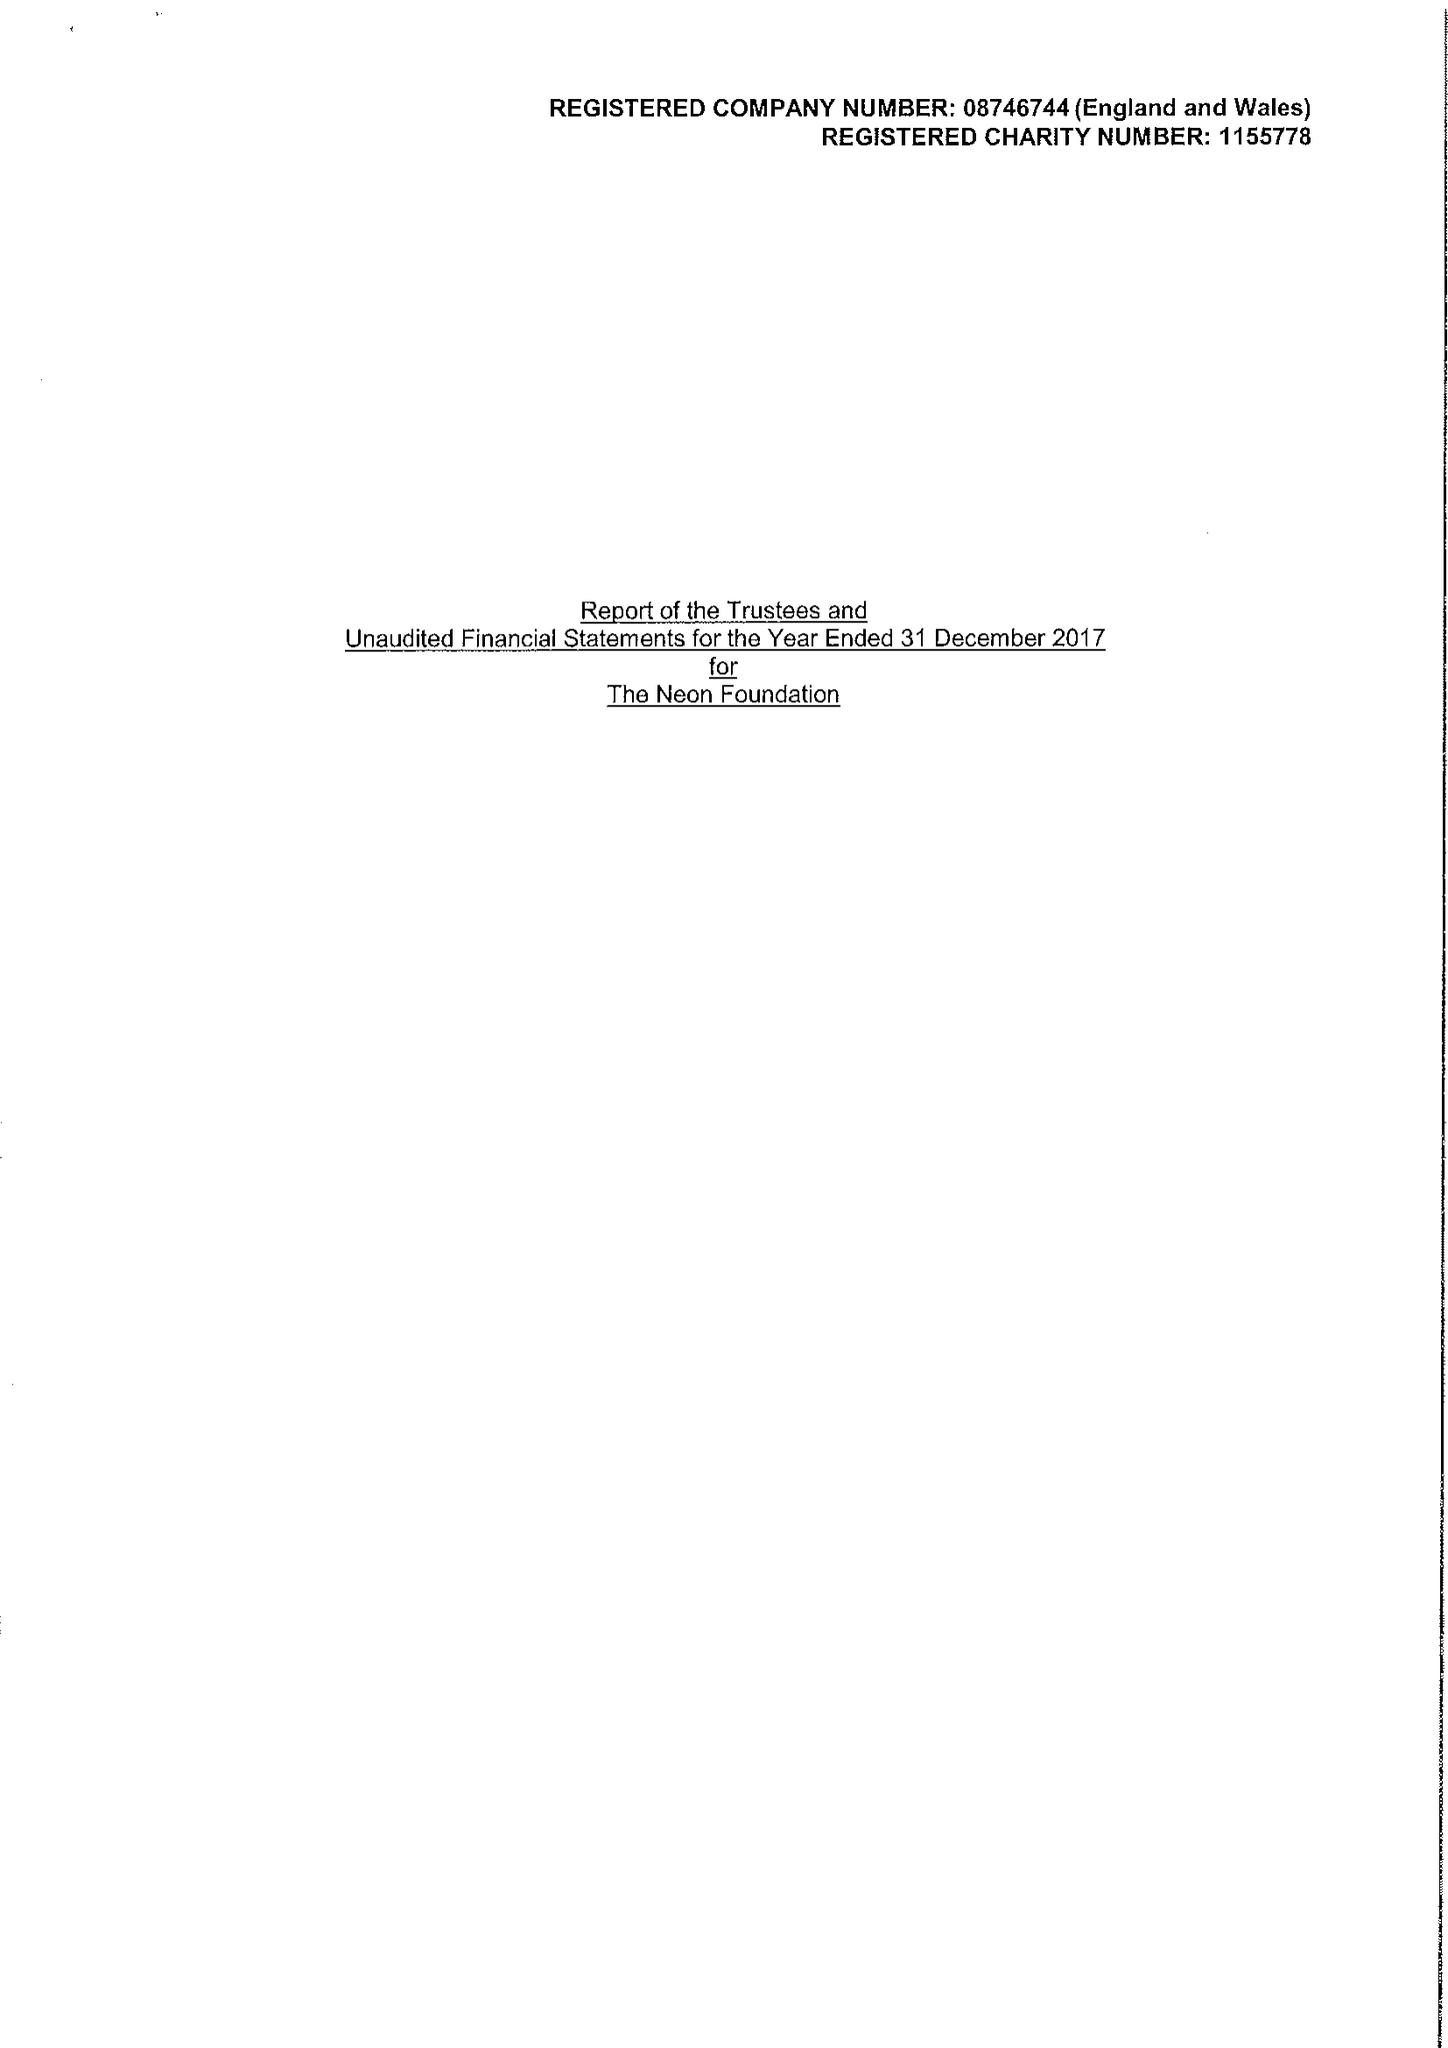What is the value for the income_annually_in_british_pounds?
Answer the question using a single word or phrase. 132700.00 